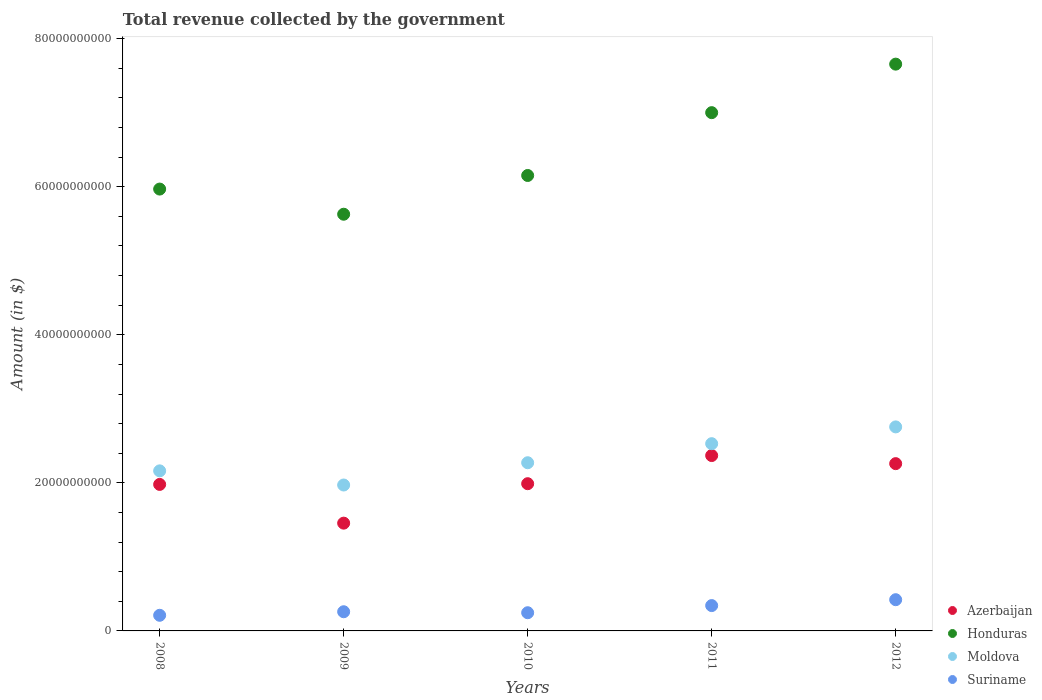How many different coloured dotlines are there?
Give a very brief answer. 4. What is the total revenue collected by the government in Azerbaijan in 2009?
Make the answer very short. 1.46e+1. Across all years, what is the maximum total revenue collected by the government in Azerbaijan?
Your answer should be very brief. 2.37e+1. Across all years, what is the minimum total revenue collected by the government in Moldova?
Provide a short and direct response. 1.97e+1. In which year was the total revenue collected by the government in Suriname minimum?
Your answer should be compact. 2008. What is the total total revenue collected by the government in Azerbaijan in the graph?
Offer a very short reply. 1.01e+11. What is the difference between the total revenue collected by the government in Moldova in 2010 and that in 2012?
Your response must be concise. -4.84e+09. What is the difference between the total revenue collected by the government in Honduras in 2009 and the total revenue collected by the government in Azerbaijan in 2012?
Provide a succinct answer. 3.37e+1. What is the average total revenue collected by the government in Azerbaijan per year?
Make the answer very short. 2.01e+1. In the year 2009, what is the difference between the total revenue collected by the government in Azerbaijan and total revenue collected by the government in Honduras?
Offer a terse response. -4.17e+1. What is the ratio of the total revenue collected by the government in Honduras in 2009 to that in 2012?
Your response must be concise. 0.74. Is the total revenue collected by the government in Suriname in 2010 less than that in 2012?
Offer a very short reply. Yes. What is the difference between the highest and the second highest total revenue collected by the government in Azerbaijan?
Offer a very short reply. 1.09e+09. What is the difference between the highest and the lowest total revenue collected by the government in Moldova?
Provide a succinct answer. 7.85e+09. Is it the case that in every year, the sum of the total revenue collected by the government in Honduras and total revenue collected by the government in Azerbaijan  is greater than the sum of total revenue collected by the government in Suriname and total revenue collected by the government in Moldova?
Your response must be concise. No. How many dotlines are there?
Your answer should be very brief. 4. How many years are there in the graph?
Your response must be concise. 5. What is the difference between two consecutive major ticks on the Y-axis?
Provide a short and direct response. 2.00e+1. Does the graph contain any zero values?
Ensure brevity in your answer.  No. Does the graph contain grids?
Your response must be concise. No. How many legend labels are there?
Offer a very short reply. 4. How are the legend labels stacked?
Make the answer very short. Vertical. What is the title of the graph?
Make the answer very short. Total revenue collected by the government. Does "Kenya" appear as one of the legend labels in the graph?
Provide a succinct answer. No. What is the label or title of the Y-axis?
Offer a very short reply. Amount (in $). What is the Amount (in $) of Azerbaijan in 2008?
Ensure brevity in your answer.  1.98e+1. What is the Amount (in $) of Honduras in 2008?
Give a very brief answer. 5.97e+1. What is the Amount (in $) of Moldova in 2008?
Give a very brief answer. 2.16e+1. What is the Amount (in $) of Suriname in 2008?
Offer a terse response. 2.11e+09. What is the Amount (in $) in Azerbaijan in 2009?
Your response must be concise. 1.46e+1. What is the Amount (in $) of Honduras in 2009?
Give a very brief answer. 5.63e+1. What is the Amount (in $) of Moldova in 2009?
Make the answer very short. 1.97e+1. What is the Amount (in $) in Suriname in 2009?
Give a very brief answer. 2.59e+09. What is the Amount (in $) in Azerbaijan in 2010?
Provide a succinct answer. 1.99e+1. What is the Amount (in $) of Honduras in 2010?
Your response must be concise. 6.15e+1. What is the Amount (in $) in Moldova in 2010?
Make the answer very short. 2.27e+1. What is the Amount (in $) in Suriname in 2010?
Your response must be concise. 2.46e+09. What is the Amount (in $) of Azerbaijan in 2011?
Provide a succinct answer. 2.37e+1. What is the Amount (in $) of Honduras in 2011?
Your answer should be compact. 7.00e+1. What is the Amount (in $) in Moldova in 2011?
Keep it short and to the point. 2.53e+1. What is the Amount (in $) of Suriname in 2011?
Make the answer very short. 3.42e+09. What is the Amount (in $) of Azerbaijan in 2012?
Keep it short and to the point. 2.26e+1. What is the Amount (in $) in Honduras in 2012?
Your response must be concise. 7.66e+1. What is the Amount (in $) in Moldova in 2012?
Offer a very short reply. 2.76e+1. What is the Amount (in $) in Suriname in 2012?
Make the answer very short. 4.22e+09. Across all years, what is the maximum Amount (in $) in Azerbaijan?
Ensure brevity in your answer.  2.37e+1. Across all years, what is the maximum Amount (in $) in Honduras?
Your answer should be compact. 7.66e+1. Across all years, what is the maximum Amount (in $) of Moldova?
Your answer should be very brief. 2.76e+1. Across all years, what is the maximum Amount (in $) in Suriname?
Make the answer very short. 4.22e+09. Across all years, what is the minimum Amount (in $) of Azerbaijan?
Give a very brief answer. 1.46e+1. Across all years, what is the minimum Amount (in $) in Honduras?
Provide a short and direct response. 5.63e+1. Across all years, what is the minimum Amount (in $) in Moldova?
Keep it short and to the point. 1.97e+1. Across all years, what is the minimum Amount (in $) of Suriname?
Make the answer very short. 2.11e+09. What is the total Amount (in $) of Azerbaijan in the graph?
Ensure brevity in your answer.  1.01e+11. What is the total Amount (in $) of Honduras in the graph?
Provide a short and direct response. 3.24e+11. What is the total Amount (in $) of Moldova in the graph?
Give a very brief answer. 1.17e+11. What is the total Amount (in $) in Suriname in the graph?
Ensure brevity in your answer.  1.48e+1. What is the difference between the Amount (in $) in Azerbaijan in 2008 and that in 2009?
Provide a short and direct response. 5.23e+09. What is the difference between the Amount (in $) in Honduras in 2008 and that in 2009?
Your answer should be very brief. 3.40e+09. What is the difference between the Amount (in $) in Moldova in 2008 and that in 2009?
Offer a very short reply. 1.91e+09. What is the difference between the Amount (in $) of Suriname in 2008 and that in 2009?
Provide a succinct answer. -4.79e+08. What is the difference between the Amount (in $) of Azerbaijan in 2008 and that in 2010?
Offer a terse response. -9.75e+07. What is the difference between the Amount (in $) in Honduras in 2008 and that in 2010?
Offer a very short reply. -1.84e+09. What is the difference between the Amount (in $) in Moldova in 2008 and that in 2010?
Make the answer very short. -1.10e+09. What is the difference between the Amount (in $) of Suriname in 2008 and that in 2010?
Provide a succinct answer. -3.46e+08. What is the difference between the Amount (in $) of Azerbaijan in 2008 and that in 2011?
Make the answer very short. -3.90e+09. What is the difference between the Amount (in $) in Honduras in 2008 and that in 2011?
Provide a short and direct response. -1.03e+1. What is the difference between the Amount (in $) in Moldova in 2008 and that in 2011?
Your response must be concise. -3.67e+09. What is the difference between the Amount (in $) in Suriname in 2008 and that in 2011?
Make the answer very short. -1.31e+09. What is the difference between the Amount (in $) in Azerbaijan in 2008 and that in 2012?
Offer a very short reply. -2.81e+09. What is the difference between the Amount (in $) of Honduras in 2008 and that in 2012?
Provide a short and direct response. -1.69e+1. What is the difference between the Amount (in $) in Moldova in 2008 and that in 2012?
Ensure brevity in your answer.  -5.94e+09. What is the difference between the Amount (in $) in Suriname in 2008 and that in 2012?
Give a very brief answer. -2.11e+09. What is the difference between the Amount (in $) in Azerbaijan in 2009 and that in 2010?
Keep it short and to the point. -5.33e+09. What is the difference between the Amount (in $) in Honduras in 2009 and that in 2010?
Give a very brief answer. -5.23e+09. What is the difference between the Amount (in $) in Moldova in 2009 and that in 2010?
Make the answer very short. -3.01e+09. What is the difference between the Amount (in $) of Suriname in 2009 and that in 2010?
Offer a very short reply. 1.34e+08. What is the difference between the Amount (in $) of Azerbaijan in 2009 and that in 2011?
Provide a succinct answer. -9.13e+09. What is the difference between the Amount (in $) of Honduras in 2009 and that in 2011?
Offer a very short reply. -1.37e+1. What is the difference between the Amount (in $) in Moldova in 2009 and that in 2011?
Provide a succinct answer. -5.58e+09. What is the difference between the Amount (in $) in Suriname in 2009 and that in 2011?
Give a very brief answer. -8.32e+08. What is the difference between the Amount (in $) in Azerbaijan in 2009 and that in 2012?
Offer a terse response. -8.04e+09. What is the difference between the Amount (in $) of Honduras in 2009 and that in 2012?
Make the answer very short. -2.03e+1. What is the difference between the Amount (in $) in Moldova in 2009 and that in 2012?
Your answer should be compact. -7.85e+09. What is the difference between the Amount (in $) in Suriname in 2009 and that in 2012?
Your answer should be very brief. -1.63e+09. What is the difference between the Amount (in $) of Azerbaijan in 2010 and that in 2011?
Offer a very short reply. -3.80e+09. What is the difference between the Amount (in $) in Honduras in 2010 and that in 2011?
Your response must be concise. -8.49e+09. What is the difference between the Amount (in $) in Moldova in 2010 and that in 2011?
Give a very brief answer. -2.57e+09. What is the difference between the Amount (in $) in Suriname in 2010 and that in 2011?
Provide a succinct answer. -9.65e+08. What is the difference between the Amount (in $) in Azerbaijan in 2010 and that in 2012?
Provide a short and direct response. -2.71e+09. What is the difference between the Amount (in $) in Honduras in 2010 and that in 2012?
Your answer should be compact. -1.50e+1. What is the difference between the Amount (in $) of Moldova in 2010 and that in 2012?
Provide a succinct answer. -4.84e+09. What is the difference between the Amount (in $) in Suriname in 2010 and that in 2012?
Make the answer very short. -1.76e+09. What is the difference between the Amount (in $) in Azerbaijan in 2011 and that in 2012?
Your response must be concise. 1.09e+09. What is the difference between the Amount (in $) in Honduras in 2011 and that in 2012?
Give a very brief answer. -6.55e+09. What is the difference between the Amount (in $) of Moldova in 2011 and that in 2012?
Give a very brief answer. -2.27e+09. What is the difference between the Amount (in $) in Suriname in 2011 and that in 2012?
Offer a very short reply. -7.95e+08. What is the difference between the Amount (in $) in Azerbaijan in 2008 and the Amount (in $) in Honduras in 2009?
Your answer should be very brief. -3.65e+1. What is the difference between the Amount (in $) of Azerbaijan in 2008 and the Amount (in $) of Moldova in 2009?
Your response must be concise. 7.93e+07. What is the difference between the Amount (in $) in Azerbaijan in 2008 and the Amount (in $) in Suriname in 2009?
Provide a succinct answer. 1.72e+1. What is the difference between the Amount (in $) of Honduras in 2008 and the Amount (in $) of Moldova in 2009?
Your answer should be compact. 4.00e+1. What is the difference between the Amount (in $) of Honduras in 2008 and the Amount (in $) of Suriname in 2009?
Provide a succinct answer. 5.71e+1. What is the difference between the Amount (in $) in Moldova in 2008 and the Amount (in $) in Suriname in 2009?
Make the answer very short. 1.90e+1. What is the difference between the Amount (in $) in Azerbaijan in 2008 and the Amount (in $) in Honduras in 2010?
Offer a very short reply. -4.17e+1. What is the difference between the Amount (in $) of Azerbaijan in 2008 and the Amount (in $) of Moldova in 2010?
Offer a terse response. -2.93e+09. What is the difference between the Amount (in $) in Azerbaijan in 2008 and the Amount (in $) in Suriname in 2010?
Provide a short and direct response. 1.73e+1. What is the difference between the Amount (in $) of Honduras in 2008 and the Amount (in $) of Moldova in 2010?
Your response must be concise. 3.70e+1. What is the difference between the Amount (in $) of Honduras in 2008 and the Amount (in $) of Suriname in 2010?
Offer a very short reply. 5.72e+1. What is the difference between the Amount (in $) in Moldova in 2008 and the Amount (in $) in Suriname in 2010?
Give a very brief answer. 1.92e+1. What is the difference between the Amount (in $) of Azerbaijan in 2008 and the Amount (in $) of Honduras in 2011?
Give a very brief answer. -5.02e+1. What is the difference between the Amount (in $) of Azerbaijan in 2008 and the Amount (in $) of Moldova in 2011?
Offer a very short reply. -5.50e+09. What is the difference between the Amount (in $) in Azerbaijan in 2008 and the Amount (in $) in Suriname in 2011?
Your answer should be very brief. 1.64e+1. What is the difference between the Amount (in $) of Honduras in 2008 and the Amount (in $) of Moldova in 2011?
Offer a very short reply. 3.44e+1. What is the difference between the Amount (in $) of Honduras in 2008 and the Amount (in $) of Suriname in 2011?
Keep it short and to the point. 5.63e+1. What is the difference between the Amount (in $) in Moldova in 2008 and the Amount (in $) in Suriname in 2011?
Offer a terse response. 1.82e+1. What is the difference between the Amount (in $) of Azerbaijan in 2008 and the Amount (in $) of Honduras in 2012?
Your answer should be very brief. -5.68e+1. What is the difference between the Amount (in $) of Azerbaijan in 2008 and the Amount (in $) of Moldova in 2012?
Offer a very short reply. -7.77e+09. What is the difference between the Amount (in $) of Azerbaijan in 2008 and the Amount (in $) of Suriname in 2012?
Your response must be concise. 1.56e+1. What is the difference between the Amount (in $) in Honduras in 2008 and the Amount (in $) in Moldova in 2012?
Your response must be concise. 3.21e+1. What is the difference between the Amount (in $) of Honduras in 2008 and the Amount (in $) of Suriname in 2012?
Give a very brief answer. 5.55e+1. What is the difference between the Amount (in $) of Moldova in 2008 and the Amount (in $) of Suriname in 2012?
Offer a very short reply. 1.74e+1. What is the difference between the Amount (in $) of Azerbaijan in 2009 and the Amount (in $) of Honduras in 2010?
Provide a succinct answer. -4.70e+1. What is the difference between the Amount (in $) in Azerbaijan in 2009 and the Amount (in $) in Moldova in 2010?
Make the answer very short. -8.16e+09. What is the difference between the Amount (in $) of Azerbaijan in 2009 and the Amount (in $) of Suriname in 2010?
Provide a short and direct response. 1.21e+1. What is the difference between the Amount (in $) of Honduras in 2009 and the Amount (in $) of Moldova in 2010?
Your answer should be very brief. 3.36e+1. What is the difference between the Amount (in $) of Honduras in 2009 and the Amount (in $) of Suriname in 2010?
Offer a terse response. 5.38e+1. What is the difference between the Amount (in $) of Moldova in 2009 and the Amount (in $) of Suriname in 2010?
Ensure brevity in your answer.  1.73e+1. What is the difference between the Amount (in $) of Azerbaijan in 2009 and the Amount (in $) of Honduras in 2011?
Make the answer very short. -5.54e+1. What is the difference between the Amount (in $) in Azerbaijan in 2009 and the Amount (in $) in Moldova in 2011?
Your answer should be very brief. -1.07e+1. What is the difference between the Amount (in $) in Azerbaijan in 2009 and the Amount (in $) in Suriname in 2011?
Keep it short and to the point. 1.11e+1. What is the difference between the Amount (in $) in Honduras in 2009 and the Amount (in $) in Moldova in 2011?
Give a very brief answer. 3.10e+1. What is the difference between the Amount (in $) in Honduras in 2009 and the Amount (in $) in Suriname in 2011?
Give a very brief answer. 5.29e+1. What is the difference between the Amount (in $) of Moldova in 2009 and the Amount (in $) of Suriname in 2011?
Provide a short and direct response. 1.63e+1. What is the difference between the Amount (in $) in Azerbaijan in 2009 and the Amount (in $) in Honduras in 2012?
Give a very brief answer. -6.20e+1. What is the difference between the Amount (in $) in Azerbaijan in 2009 and the Amount (in $) in Moldova in 2012?
Your answer should be compact. -1.30e+1. What is the difference between the Amount (in $) in Azerbaijan in 2009 and the Amount (in $) in Suriname in 2012?
Offer a terse response. 1.03e+1. What is the difference between the Amount (in $) of Honduras in 2009 and the Amount (in $) of Moldova in 2012?
Keep it short and to the point. 2.87e+1. What is the difference between the Amount (in $) of Honduras in 2009 and the Amount (in $) of Suriname in 2012?
Your answer should be very brief. 5.21e+1. What is the difference between the Amount (in $) of Moldova in 2009 and the Amount (in $) of Suriname in 2012?
Give a very brief answer. 1.55e+1. What is the difference between the Amount (in $) in Azerbaijan in 2010 and the Amount (in $) in Honduras in 2011?
Your answer should be very brief. -5.01e+1. What is the difference between the Amount (in $) in Azerbaijan in 2010 and the Amount (in $) in Moldova in 2011?
Ensure brevity in your answer.  -5.41e+09. What is the difference between the Amount (in $) of Azerbaijan in 2010 and the Amount (in $) of Suriname in 2011?
Offer a very short reply. 1.65e+1. What is the difference between the Amount (in $) of Honduras in 2010 and the Amount (in $) of Moldova in 2011?
Make the answer very short. 3.62e+1. What is the difference between the Amount (in $) of Honduras in 2010 and the Amount (in $) of Suriname in 2011?
Your response must be concise. 5.81e+1. What is the difference between the Amount (in $) in Moldova in 2010 and the Amount (in $) in Suriname in 2011?
Your answer should be compact. 1.93e+1. What is the difference between the Amount (in $) in Azerbaijan in 2010 and the Amount (in $) in Honduras in 2012?
Ensure brevity in your answer.  -5.67e+1. What is the difference between the Amount (in $) in Azerbaijan in 2010 and the Amount (in $) in Moldova in 2012?
Your answer should be compact. -7.67e+09. What is the difference between the Amount (in $) in Azerbaijan in 2010 and the Amount (in $) in Suriname in 2012?
Offer a very short reply. 1.57e+1. What is the difference between the Amount (in $) of Honduras in 2010 and the Amount (in $) of Moldova in 2012?
Provide a succinct answer. 3.40e+1. What is the difference between the Amount (in $) in Honduras in 2010 and the Amount (in $) in Suriname in 2012?
Make the answer very short. 5.73e+1. What is the difference between the Amount (in $) in Moldova in 2010 and the Amount (in $) in Suriname in 2012?
Ensure brevity in your answer.  1.85e+1. What is the difference between the Amount (in $) in Azerbaijan in 2011 and the Amount (in $) in Honduras in 2012?
Your answer should be compact. -5.29e+1. What is the difference between the Amount (in $) of Azerbaijan in 2011 and the Amount (in $) of Moldova in 2012?
Provide a succinct answer. -3.87e+09. What is the difference between the Amount (in $) of Azerbaijan in 2011 and the Amount (in $) of Suriname in 2012?
Offer a terse response. 1.95e+1. What is the difference between the Amount (in $) in Honduras in 2011 and the Amount (in $) in Moldova in 2012?
Give a very brief answer. 4.24e+1. What is the difference between the Amount (in $) in Honduras in 2011 and the Amount (in $) in Suriname in 2012?
Provide a succinct answer. 6.58e+1. What is the difference between the Amount (in $) in Moldova in 2011 and the Amount (in $) in Suriname in 2012?
Provide a short and direct response. 2.11e+1. What is the average Amount (in $) in Azerbaijan per year?
Provide a short and direct response. 2.01e+1. What is the average Amount (in $) of Honduras per year?
Make the answer very short. 6.48e+1. What is the average Amount (in $) of Moldova per year?
Provide a short and direct response. 2.34e+1. What is the average Amount (in $) in Suriname per year?
Provide a succinct answer. 2.96e+09. In the year 2008, what is the difference between the Amount (in $) in Azerbaijan and Amount (in $) in Honduras?
Provide a succinct answer. -3.99e+1. In the year 2008, what is the difference between the Amount (in $) in Azerbaijan and Amount (in $) in Moldova?
Ensure brevity in your answer.  -1.83e+09. In the year 2008, what is the difference between the Amount (in $) of Azerbaijan and Amount (in $) of Suriname?
Make the answer very short. 1.77e+1. In the year 2008, what is the difference between the Amount (in $) in Honduras and Amount (in $) in Moldova?
Offer a terse response. 3.81e+1. In the year 2008, what is the difference between the Amount (in $) of Honduras and Amount (in $) of Suriname?
Offer a very short reply. 5.76e+1. In the year 2008, what is the difference between the Amount (in $) of Moldova and Amount (in $) of Suriname?
Provide a short and direct response. 1.95e+1. In the year 2009, what is the difference between the Amount (in $) in Azerbaijan and Amount (in $) in Honduras?
Your answer should be very brief. -4.17e+1. In the year 2009, what is the difference between the Amount (in $) of Azerbaijan and Amount (in $) of Moldova?
Make the answer very short. -5.15e+09. In the year 2009, what is the difference between the Amount (in $) in Azerbaijan and Amount (in $) in Suriname?
Provide a short and direct response. 1.20e+1. In the year 2009, what is the difference between the Amount (in $) of Honduras and Amount (in $) of Moldova?
Offer a very short reply. 3.66e+1. In the year 2009, what is the difference between the Amount (in $) in Honduras and Amount (in $) in Suriname?
Your answer should be very brief. 5.37e+1. In the year 2009, what is the difference between the Amount (in $) of Moldova and Amount (in $) of Suriname?
Your answer should be very brief. 1.71e+1. In the year 2010, what is the difference between the Amount (in $) of Azerbaijan and Amount (in $) of Honduras?
Ensure brevity in your answer.  -4.16e+1. In the year 2010, what is the difference between the Amount (in $) in Azerbaijan and Amount (in $) in Moldova?
Offer a very short reply. -2.83e+09. In the year 2010, what is the difference between the Amount (in $) in Azerbaijan and Amount (in $) in Suriname?
Ensure brevity in your answer.  1.74e+1. In the year 2010, what is the difference between the Amount (in $) in Honduras and Amount (in $) in Moldova?
Your answer should be very brief. 3.88e+1. In the year 2010, what is the difference between the Amount (in $) in Honduras and Amount (in $) in Suriname?
Keep it short and to the point. 5.91e+1. In the year 2010, what is the difference between the Amount (in $) of Moldova and Amount (in $) of Suriname?
Your answer should be compact. 2.03e+1. In the year 2011, what is the difference between the Amount (in $) of Azerbaijan and Amount (in $) of Honduras?
Your response must be concise. -4.63e+1. In the year 2011, what is the difference between the Amount (in $) in Azerbaijan and Amount (in $) in Moldova?
Ensure brevity in your answer.  -1.60e+09. In the year 2011, what is the difference between the Amount (in $) of Azerbaijan and Amount (in $) of Suriname?
Offer a very short reply. 2.03e+1. In the year 2011, what is the difference between the Amount (in $) in Honduras and Amount (in $) in Moldova?
Ensure brevity in your answer.  4.47e+1. In the year 2011, what is the difference between the Amount (in $) of Honduras and Amount (in $) of Suriname?
Keep it short and to the point. 6.66e+1. In the year 2011, what is the difference between the Amount (in $) in Moldova and Amount (in $) in Suriname?
Make the answer very short. 2.19e+1. In the year 2012, what is the difference between the Amount (in $) in Azerbaijan and Amount (in $) in Honduras?
Keep it short and to the point. -5.40e+1. In the year 2012, what is the difference between the Amount (in $) of Azerbaijan and Amount (in $) of Moldova?
Keep it short and to the point. -4.96e+09. In the year 2012, what is the difference between the Amount (in $) of Azerbaijan and Amount (in $) of Suriname?
Ensure brevity in your answer.  1.84e+1. In the year 2012, what is the difference between the Amount (in $) in Honduras and Amount (in $) in Moldova?
Your answer should be compact. 4.90e+1. In the year 2012, what is the difference between the Amount (in $) of Honduras and Amount (in $) of Suriname?
Offer a terse response. 7.23e+1. In the year 2012, what is the difference between the Amount (in $) of Moldova and Amount (in $) of Suriname?
Make the answer very short. 2.33e+1. What is the ratio of the Amount (in $) of Azerbaijan in 2008 to that in 2009?
Your response must be concise. 1.36. What is the ratio of the Amount (in $) of Honduras in 2008 to that in 2009?
Keep it short and to the point. 1.06. What is the ratio of the Amount (in $) of Moldova in 2008 to that in 2009?
Make the answer very short. 1.1. What is the ratio of the Amount (in $) in Suriname in 2008 to that in 2009?
Your answer should be very brief. 0.81. What is the ratio of the Amount (in $) of Honduras in 2008 to that in 2010?
Your response must be concise. 0.97. What is the ratio of the Amount (in $) of Moldova in 2008 to that in 2010?
Offer a very short reply. 0.95. What is the ratio of the Amount (in $) in Suriname in 2008 to that in 2010?
Provide a short and direct response. 0.86. What is the ratio of the Amount (in $) of Azerbaijan in 2008 to that in 2011?
Offer a very short reply. 0.84. What is the ratio of the Amount (in $) of Honduras in 2008 to that in 2011?
Your answer should be very brief. 0.85. What is the ratio of the Amount (in $) in Moldova in 2008 to that in 2011?
Provide a succinct answer. 0.85. What is the ratio of the Amount (in $) in Suriname in 2008 to that in 2011?
Keep it short and to the point. 0.62. What is the ratio of the Amount (in $) of Azerbaijan in 2008 to that in 2012?
Offer a terse response. 0.88. What is the ratio of the Amount (in $) in Honduras in 2008 to that in 2012?
Make the answer very short. 0.78. What is the ratio of the Amount (in $) in Moldova in 2008 to that in 2012?
Your answer should be compact. 0.78. What is the ratio of the Amount (in $) of Suriname in 2008 to that in 2012?
Keep it short and to the point. 0.5. What is the ratio of the Amount (in $) of Azerbaijan in 2009 to that in 2010?
Offer a very short reply. 0.73. What is the ratio of the Amount (in $) of Honduras in 2009 to that in 2010?
Keep it short and to the point. 0.91. What is the ratio of the Amount (in $) in Moldova in 2009 to that in 2010?
Provide a succinct answer. 0.87. What is the ratio of the Amount (in $) in Suriname in 2009 to that in 2010?
Your response must be concise. 1.05. What is the ratio of the Amount (in $) of Azerbaijan in 2009 to that in 2011?
Provide a short and direct response. 0.61. What is the ratio of the Amount (in $) of Honduras in 2009 to that in 2011?
Provide a short and direct response. 0.8. What is the ratio of the Amount (in $) in Moldova in 2009 to that in 2011?
Offer a terse response. 0.78. What is the ratio of the Amount (in $) of Suriname in 2009 to that in 2011?
Offer a very short reply. 0.76. What is the ratio of the Amount (in $) in Azerbaijan in 2009 to that in 2012?
Provide a succinct answer. 0.64. What is the ratio of the Amount (in $) in Honduras in 2009 to that in 2012?
Your response must be concise. 0.74. What is the ratio of the Amount (in $) of Moldova in 2009 to that in 2012?
Provide a succinct answer. 0.72. What is the ratio of the Amount (in $) of Suriname in 2009 to that in 2012?
Your answer should be compact. 0.61. What is the ratio of the Amount (in $) of Azerbaijan in 2010 to that in 2011?
Make the answer very short. 0.84. What is the ratio of the Amount (in $) in Honduras in 2010 to that in 2011?
Ensure brevity in your answer.  0.88. What is the ratio of the Amount (in $) in Moldova in 2010 to that in 2011?
Provide a succinct answer. 0.9. What is the ratio of the Amount (in $) of Suriname in 2010 to that in 2011?
Offer a very short reply. 0.72. What is the ratio of the Amount (in $) of Azerbaijan in 2010 to that in 2012?
Your response must be concise. 0.88. What is the ratio of the Amount (in $) of Honduras in 2010 to that in 2012?
Provide a short and direct response. 0.8. What is the ratio of the Amount (in $) in Moldova in 2010 to that in 2012?
Your response must be concise. 0.82. What is the ratio of the Amount (in $) in Suriname in 2010 to that in 2012?
Offer a very short reply. 0.58. What is the ratio of the Amount (in $) in Azerbaijan in 2011 to that in 2012?
Give a very brief answer. 1.05. What is the ratio of the Amount (in $) in Honduras in 2011 to that in 2012?
Provide a succinct answer. 0.91. What is the ratio of the Amount (in $) in Moldova in 2011 to that in 2012?
Provide a short and direct response. 0.92. What is the ratio of the Amount (in $) in Suriname in 2011 to that in 2012?
Offer a very short reply. 0.81. What is the difference between the highest and the second highest Amount (in $) of Azerbaijan?
Provide a succinct answer. 1.09e+09. What is the difference between the highest and the second highest Amount (in $) in Honduras?
Offer a very short reply. 6.55e+09. What is the difference between the highest and the second highest Amount (in $) of Moldova?
Provide a succinct answer. 2.27e+09. What is the difference between the highest and the second highest Amount (in $) of Suriname?
Offer a terse response. 7.95e+08. What is the difference between the highest and the lowest Amount (in $) in Azerbaijan?
Make the answer very short. 9.13e+09. What is the difference between the highest and the lowest Amount (in $) in Honduras?
Give a very brief answer. 2.03e+1. What is the difference between the highest and the lowest Amount (in $) of Moldova?
Keep it short and to the point. 7.85e+09. What is the difference between the highest and the lowest Amount (in $) of Suriname?
Keep it short and to the point. 2.11e+09. 